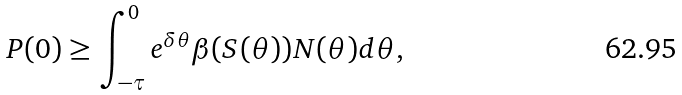Convert formula to latex. <formula><loc_0><loc_0><loc_500><loc_500>P ( 0 ) \geq \int _ { - \tau } ^ { 0 } e ^ { \delta \theta } \beta ( S ( \theta ) ) N ( \theta ) d \theta ,</formula> 